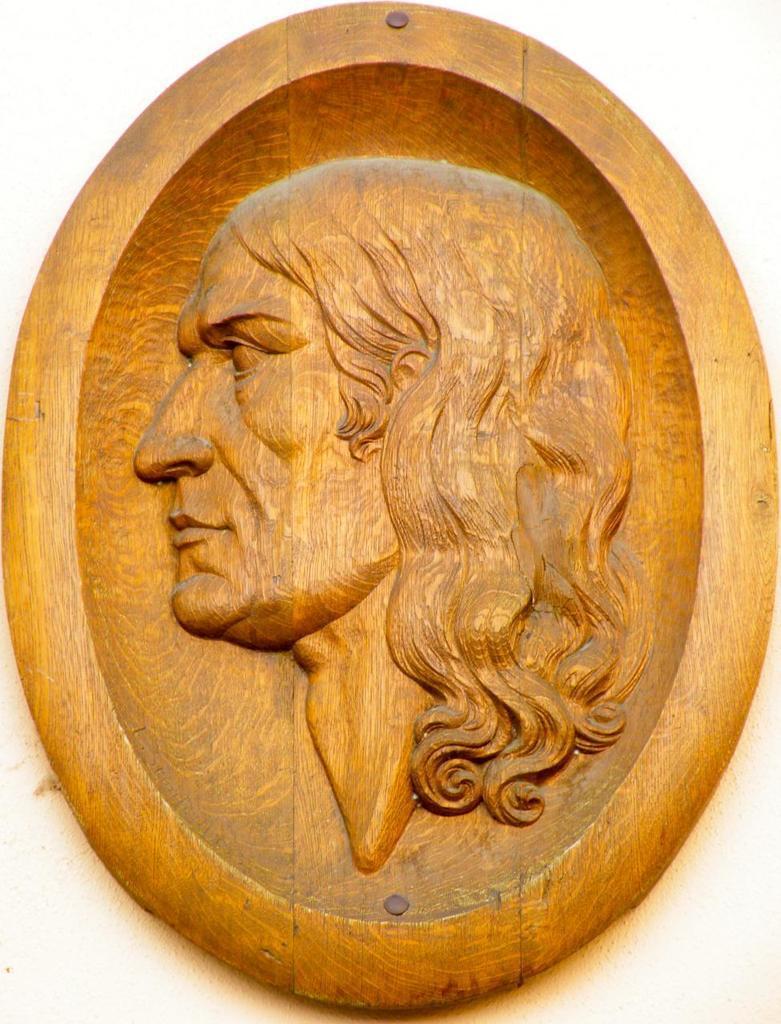How would you summarize this image in a sentence or two? In this image there is a wooden frame on which there is a carving of a person. 